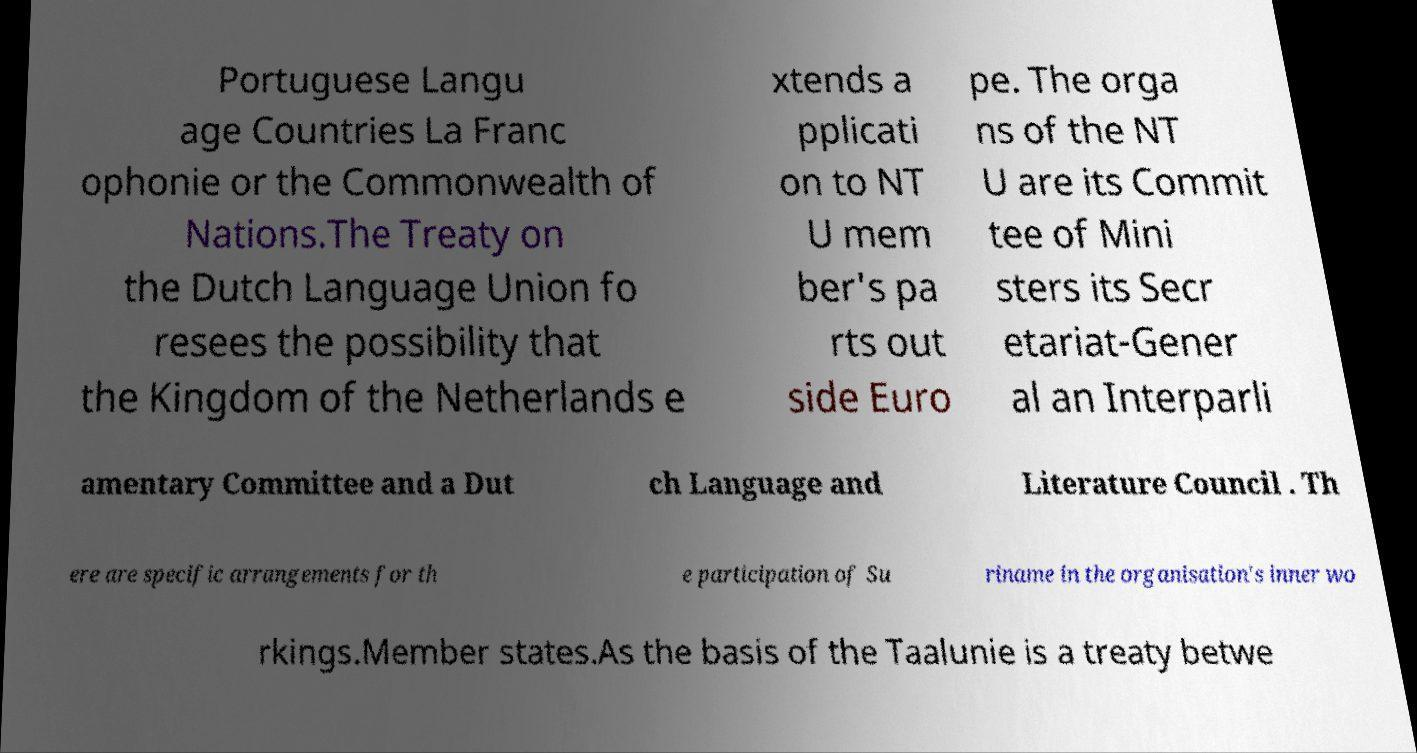Could you assist in decoding the text presented in this image and type it out clearly? Portuguese Langu age Countries La Franc ophonie or the Commonwealth of Nations.The Treaty on the Dutch Language Union fo resees the possibility that the Kingdom of the Netherlands e xtends a pplicati on to NT U mem ber's pa rts out side Euro pe. The orga ns of the NT U are its Commit tee of Mini sters its Secr etariat-Gener al an Interparli amentary Committee and a Dut ch Language and Literature Council . Th ere are specific arrangements for th e participation of Su riname in the organisation's inner wo rkings.Member states.As the basis of the Taalunie is a treaty betwe 